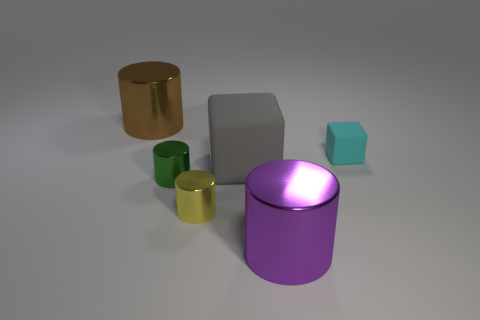Add 1 small shiny things. How many objects exist? 7 Subtract all blocks. How many objects are left? 4 Add 2 gray objects. How many gray objects exist? 3 Subtract 1 cyan blocks. How many objects are left? 5 Subtract all large yellow objects. Subtract all metallic cylinders. How many objects are left? 2 Add 4 rubber blocks. How many rubber blocks are left? 6 